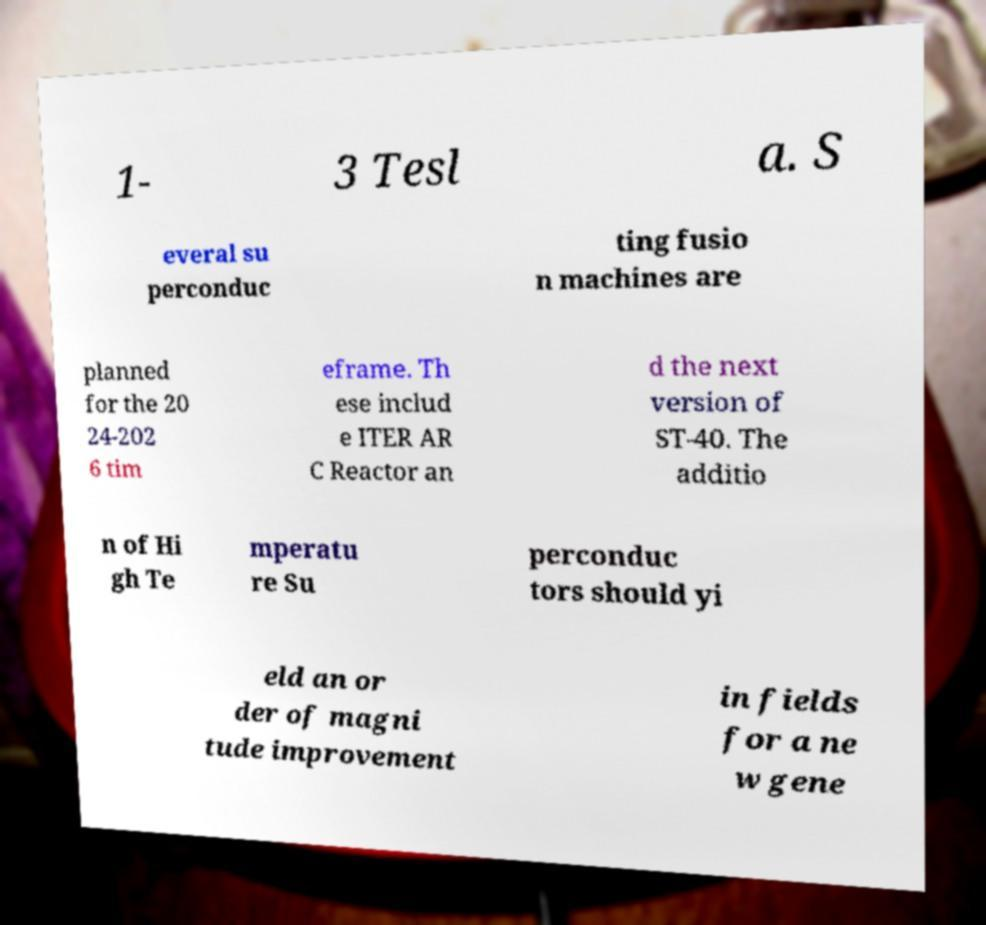I need the written content from this picture converted into text. Can you do that? 1- 3 Tesl a. S everal su perconduc ting fusio n machines are planned for the 20 24-202 6 tim eframe. Th ese includ e ITER AR C Reactor an d the next version of ST-40. The additio n of Hi gh Te mperatu re Su perconduc tors should yi eld an or der of magni tude improvement in fields for a ne w gene 